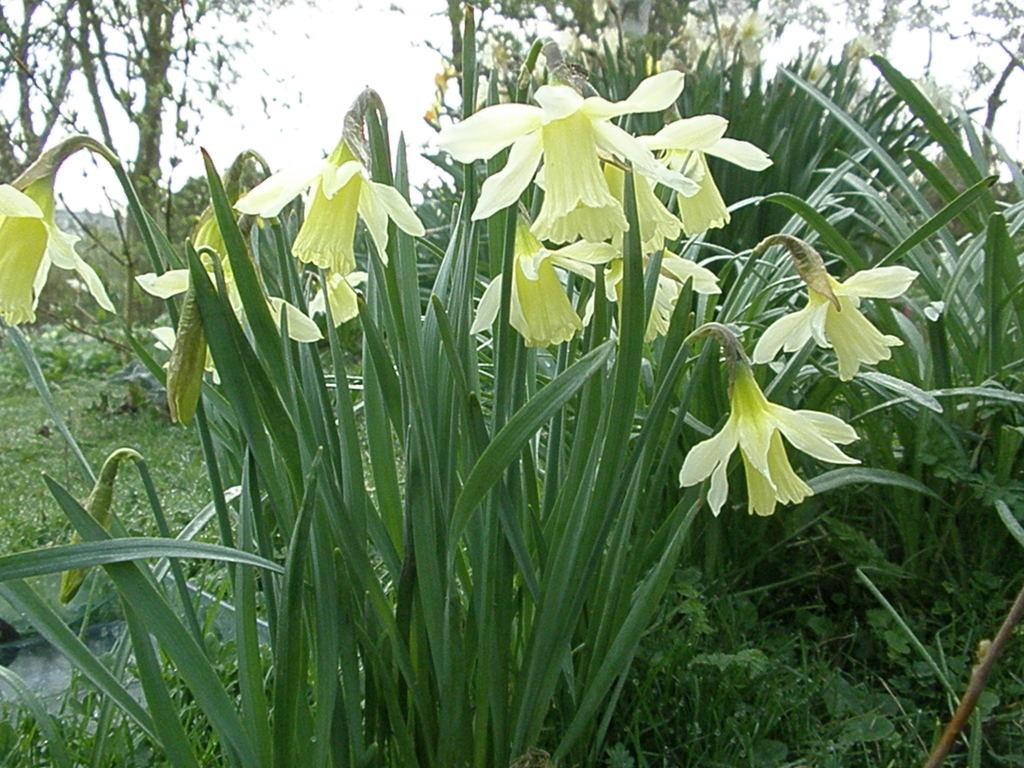What type of vegetation can be seen in the image? There are plants and flowers in the image. What can be seen in the background of the image? There are trees in the background of the image. What is visible in the image besides the plants and flowers? There is water visible in the image. How would you describe the sky in the image? The sky is cloudy in the image. What arithmetic problem is being solved by the flowers in the image? There is no arithmetic problem being solved by the flowers in the image, as flowers do not have the ability to perform arithmetic. 